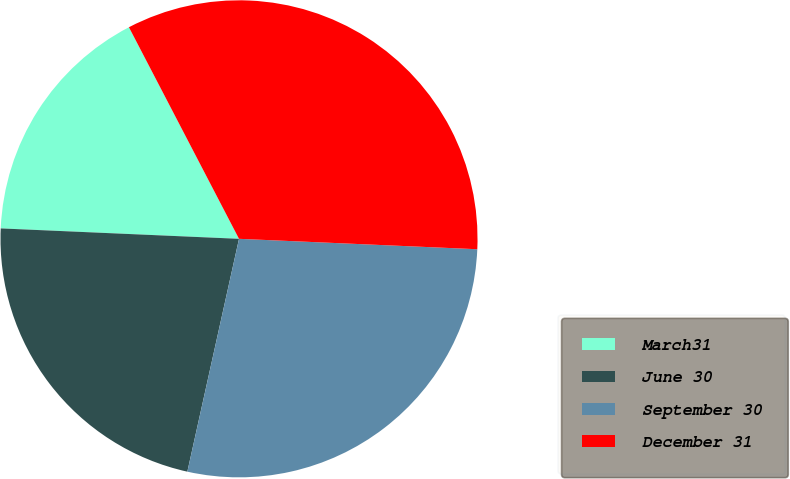<chart> <loc_0><loc_0><loc_500><loc_500><pie_chart><fcel>March31<fcel>June 30<fcel>September 30<fcel>December 31<nl><fcel>16.67%<fcel>22.22%<fcel>27.78%<fcel>33.33%<nl></chart> 